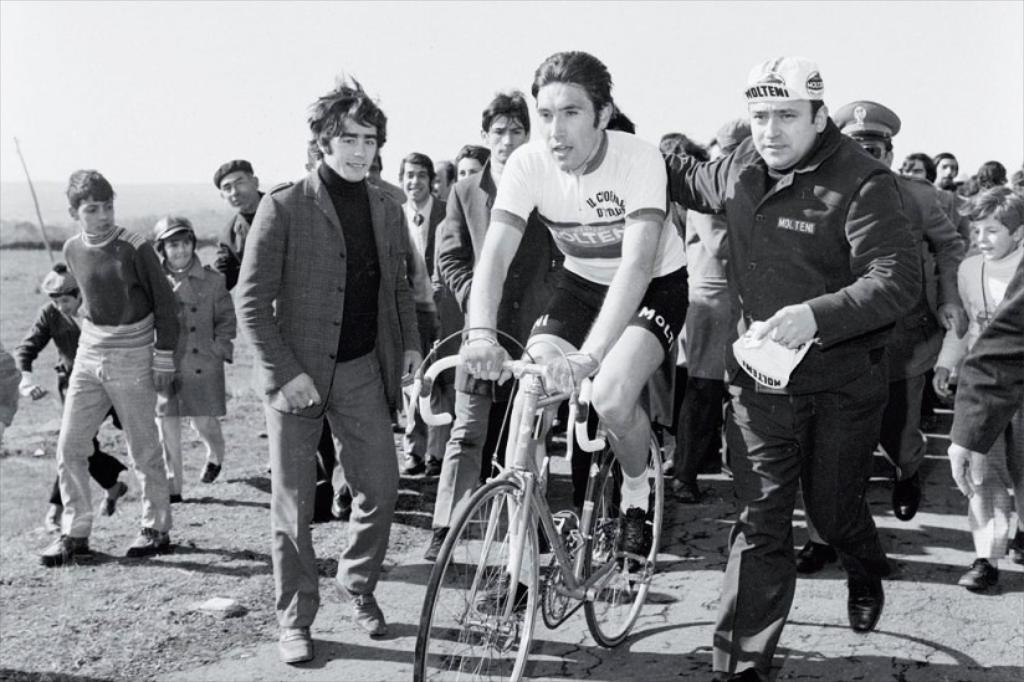How many individuals are present in the image? There are many people in the image. What activity is one person engaged in? There is a person riding a bicycle. What are the other people doing in relation to the person on the bicycle? People are walking around the person riding the bicycle. What type of star can be seen in the image? There is no star present in the image. Is there a party happening in the image? The image does not depict a party or any party-related activities. 